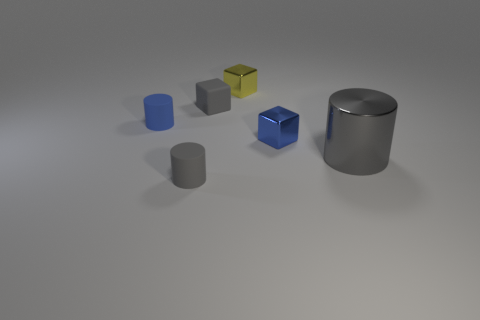There is a big gray object that is on the right side of the small blue block; is there a small gray cylinder right of it?
Make the answer very short. No. There is a blue matte thing; is its shape the same as the small gray thing that is in front of the small blue shiny block?
Your answer should be compact. Yes. How big is the cylinder that is both behind the tiny gray rubber cylinder and on the right side of the tiny blue cylinder?
Keep it short and to the point. Large. Is there a tiny yellow thing that has the same material as the big gray object?
Make the answer very short. Yes. What size is the rubber thing that is the same color as the matte block?
Provide a succinct answer. Small. What material is the tiny cube that is in front of the cylinder behind the big gray metal object?
Make the answer very short. Metal. What number of tiny rubber blocks are the same color as the large metal cylinder?
Offer a terse response. 1. There is another block that is the same material as the yellow block; what size is it?
Keep it short and to the point. Small. There is a tiny metallic thing that is to the right of the tiny yellow metallic thing; what is its shape?
Give a very brief answer. Cube. There is a metal object that is the same shape as the small blue rubber object; what size is it?
Ensure brevity in your answer.  Large. 